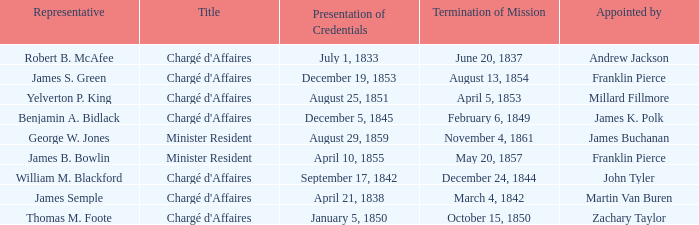Would you mind parsing the complete table? {'header': ['Representative', 'Title', 'Presentation of Credentials', 'Termination of Mission', 'Appointed by'], 'rows': [['Robert B. McAfee', "Chargé d'Affaires", 'July 1, 1833', 'June 20, 1837', 'Andrew Jackson'], ['James S. Green', "Chargé d'Affaires", 'December 19, 1853', 'August 13, 1854', 'Franklin Pierce'], ['Yelverton P. King', "Chargé d'Affaires", 'August 25, 1851', 'April 5, 1853', 'Millard Fillmore'], ['Benjamin A. Bidlack', "Chargé d'Affaires", 'December 5, 1845', 'February 6, 1849', 'James K. Polk'], ['George W. Jones', 'Minister Resident', 'August 29, 1859', 'November 4, 1861', 'James Buchanan'], ['James B. Bowlin', 'Minister Resident', 'April 10, 1855', 'May 20, 1857', 'Franklin Pierce'], ['William M. Blackford', "Chargé d'Affaires", 'September 17, 1842', 'December 24, 1844', 'John Tyler'], ['James Semple', "Chargé d'Affaires", 'April 21, 1838', 'March 4, 1842', 'Martin Van Buren'], ['Thomas M. Foote', "Chargé d'Affaires", 'January 5, 1850', 'October 15, 1850', 'Zachary Taylor']]} Which Title has an Appointed by of Millard Fillmore? Chargé d'Affaires. 